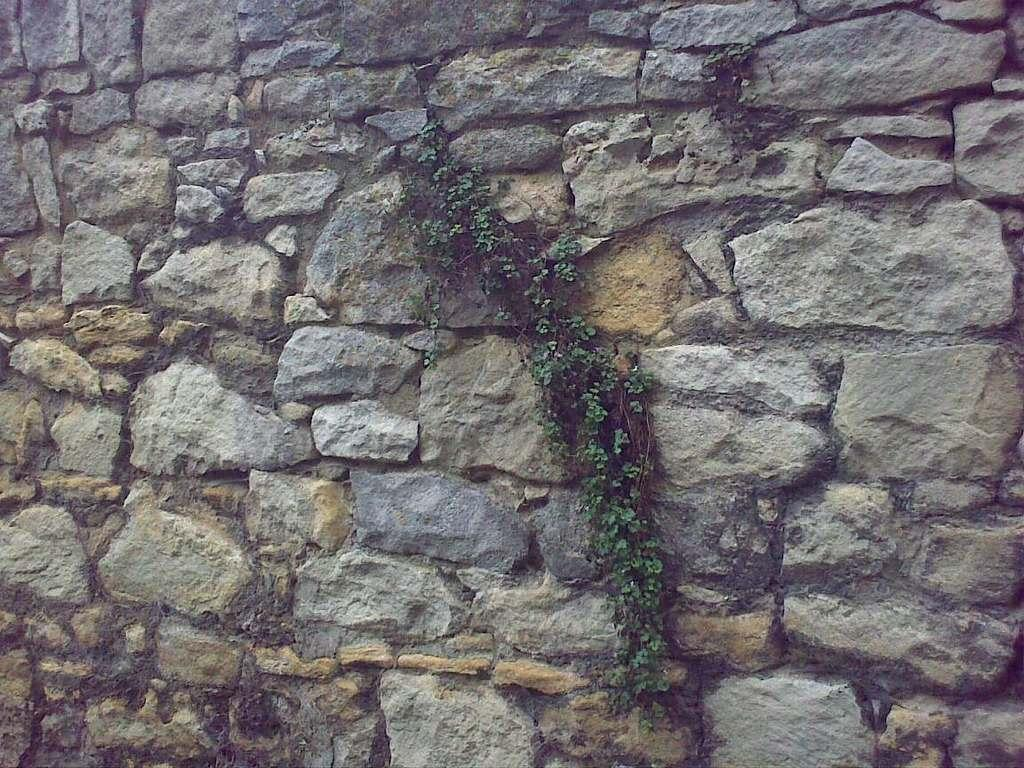What type of structure is visible in the image? There is a stone wall in the image. Can you describe the stones on the wall? The stones on the wall vary in size. Is there any vegetation present on the stone wall? Yes, there is a plant on the stone wall. What is the price of the key shown on the stone wall in the image? There is no key present in the image, so it is not possible to determine its price. 